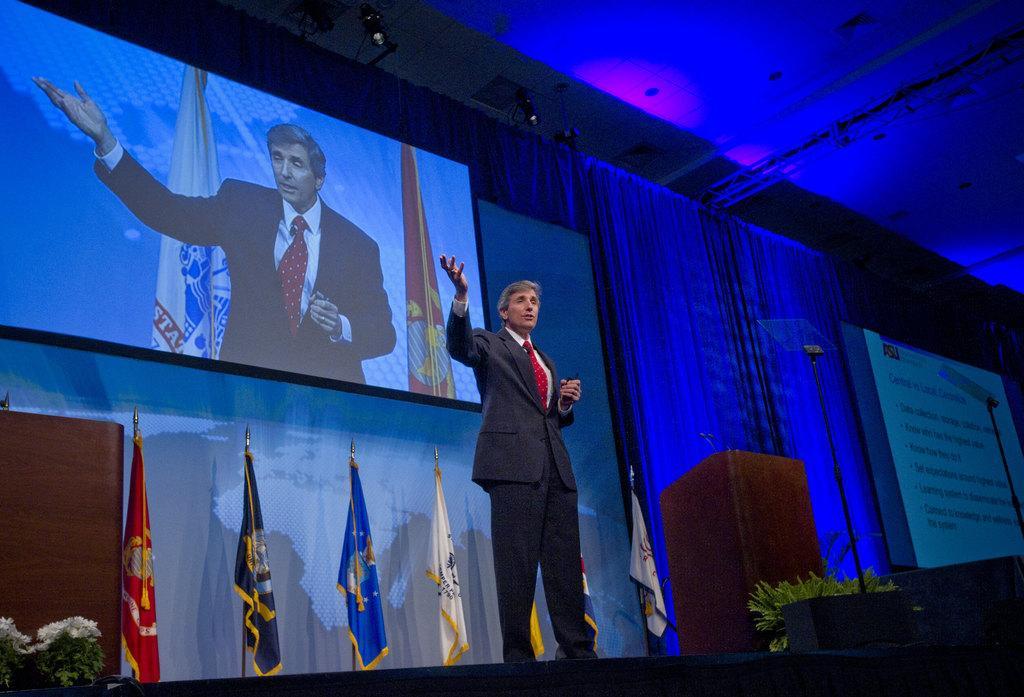In one or two sentences, can you explain what this image depicts? In the middle of the picture, we see the man in the black blazer is standing. He is trying to explain something. Beside him, we see the podium and the microphone. Beside that, we see the plant pots. Behind him, we see the flags in white, grey, blue, yellow and red color. On the left side, we see the podium and the flowertots. In the background, we see the screen which is displaying the man and the flags. Behind that, we see a sheet. On the right side, we see the white board or the projector screen with some text displayed on it. At the top, we see the ceiling of the room. This picture might be clicked in the conference hall. 